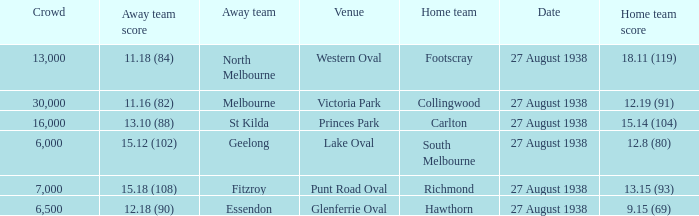Which home team had the away team score 15.18 (108) against them? 13.15 (93). 